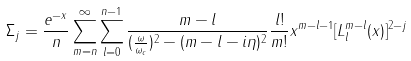<formula> <loc_0><loc_0><loc_500><loc_500>\Sigma _ { j } = \frac { e ^ { - x } } { n } \sum _ { m = n } ^ { \infty } \sum _ { l = 0 } ^ { n - 1 } \frac { m - l } { ( \frac { \omega } { \omega _ { c } } ) ^ { 2 } - ( m - l - i \eta ) ^ { 2 } } \frac { l ! } { m ! } x ^ { m - l - 1 } [ L _ { l } ^ { m - l } ( x ) ] ^ { 2 - j }</formula> 